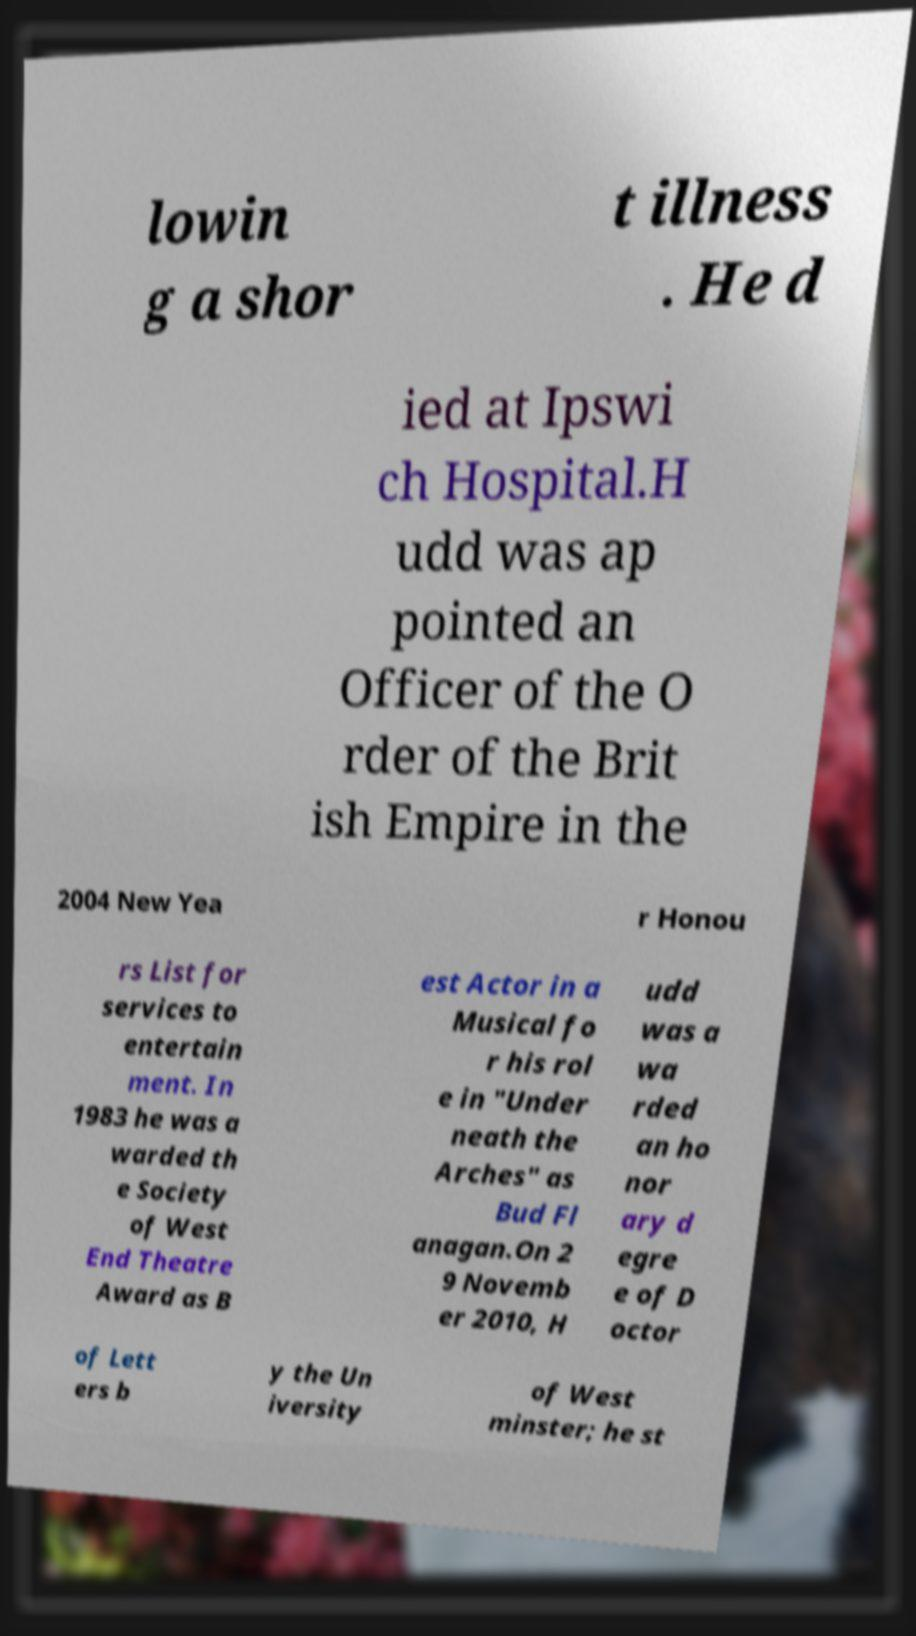Can you accurately transcribe the text from the provided image for me? lowin g a shor t illness . He d ied at Ipswi ch Hospital.H udd was ap pointed an Officer of the O rder of the Brit ish Empire in the 2004 New Yea r Honou rs List for services to entertain ment. In 1983 he was a warded th e Society of West End Theatre Award as B est Actor in a Musical fo r his rol e in "Under neath the Arches" as Bud Fl anagan.On 2 9 Novemb er 2010, H udd was a wa rded an ho nor ary d egre e of D octor of Lett ers b y the Un iversity of West minster; he st 